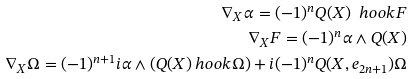Convert formula to latex. <formula><loc_0><loc_0><loc_500><loc_500>\nabla _ { X } \alpha = ( - 1 ) ^ { n } Q ( X ) \ h o o k F \\ \nabla _ { X } F = ( - 1 ) ^ { n } \alpha \wedge Q ( X ) \\ \nabla _ { X } \Omega = ( - 1 ) ^ { n + 1 } i \alpha \wedge ( Q ( X ) \ h o o k \Omega ) + i ( - 1 ) ^ { n } Q ( X , e _ { 2 n + 1 } ) \Omega</formula> 